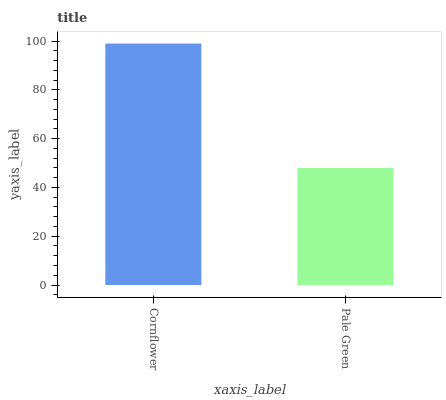Is Pale Green the minimum?
Answer yes or no. Yes. Is Cornflower the maximum?
Answer yes or no. Yes. Is Pale Green the maximum?
Answer yes or no. No. Is Cornflower greater than Pale Green?
Answer yes or no. Yes. Is Pale Green less than Cornflower?
Answer yes or no. Yes. Is Pale Green greater than Cornflower?
Answer yes or no. No. Is Cornflower less than Pale Green?
Answer yes or no. No. Is Cornflower the high median?
Answer yes or no. Yes. Is Pale Green the low median?
Answer yes or no. Yes. Is Pale Green the high median?
Answer yes or no. No. Is Cornflower the low median?
Answer yes or no. No. 